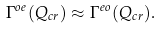<formula> <loc_0><loc_0><loc_500><loc_500>\Gamma ^ { o e } ( Q _ { c r } ) \approx \Gamma ^ { e o } ( Q _ { c r } ) .</formula> 